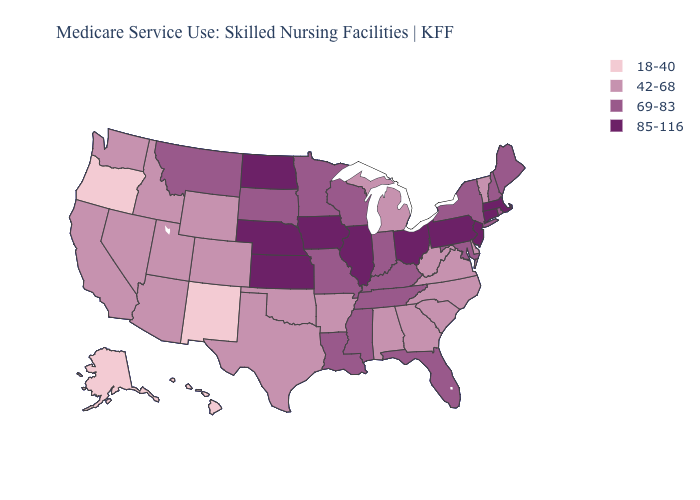Does Florida have the highest value in the South?
Concise answer only. Yes. Does the first symbol in the legend represent the smallest category?
Give a very brief answer. Yes. What is the value of Delaware?
Be succinct. 42-68. What is the value of Connecticut?
Concise answer only. 85-116. Name the states that have a value in the range 69-83?
Keep it brief. Florida, Indiana, Kentucky, Louisiana, Maine, Maryland, Minnesota, Mississippi, Missouri, Montana, New Hampshire, New York, Rhode Island, South Dakota, Tennessee, Wisconsin. Name the states that have a value in the range 69-83?
Be succinct. Florida, Indiana, Kentucky, Louisiana, Maine, Maryland, Minnesota, Mississippi, Missouri, Montana, New Hampshire, New York, Rhode Island, South Dakota, Tennessee, Wisconsin. Among the states that border Connecticut , which have the highest value?
Quick response, please. Massachusetts. Which states have the lowest value in the Northeast?
Write a very short answer. Vermont. What is the highest value in the MidWest ?
Give a very brief answer. 85-116. Which states have the lowest value in the USA?
Give a very brief answer. Alaska, Hawaii, New Mexico, Oregon. Name the states that have a value in the range 18-40?
Answer briefly. Alaska, Hawaii, New Mexico, Oregon. Name the states that have a value in the range 42-68?
Write a very short answer. Alabama, Arizona, Arkansas, California, Colorado, Delaware, Georgia, Idaho, Michigan, Nevada, North Carolina, Oklahoma, South Carolina, Texas, Utah, Vermont, Virginia, Washington, West Virginia, Wyoming. What is the value of Missouri?
Answer briefly. 69-83. Among the states that border Colorado , which have the highest value?
Keep it brief. Kansas, Nebraska. Among the states that border South Carolina , which have the highest value?
Quick response, please. Georgia, North Carolina. 